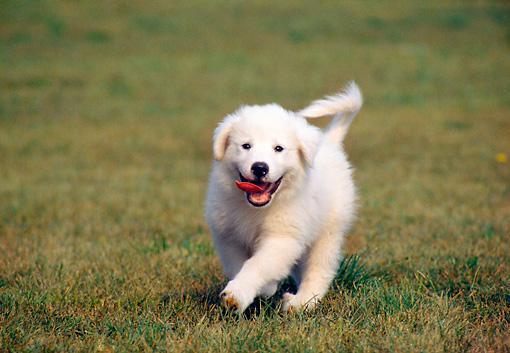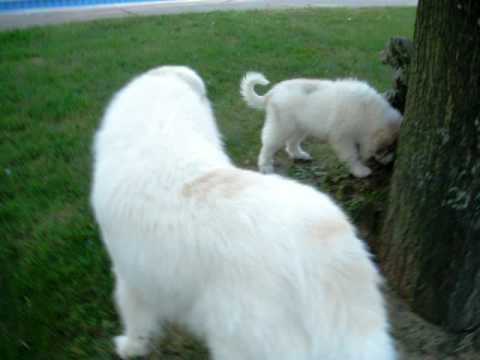The first image is the image on the left, the second image is the image on the right. Examine the images to the left and right. Is the description "An image shows a dog running across the grass with its tongue sticking out and to one side." accurate? Answer yes or no. Yes. The first image is the image on the left, the second image is the image on the right. For the images displayed, is the sentence "The dog in the image on the left is running through the grass." factually correct? Answer yes or no. Yes. 